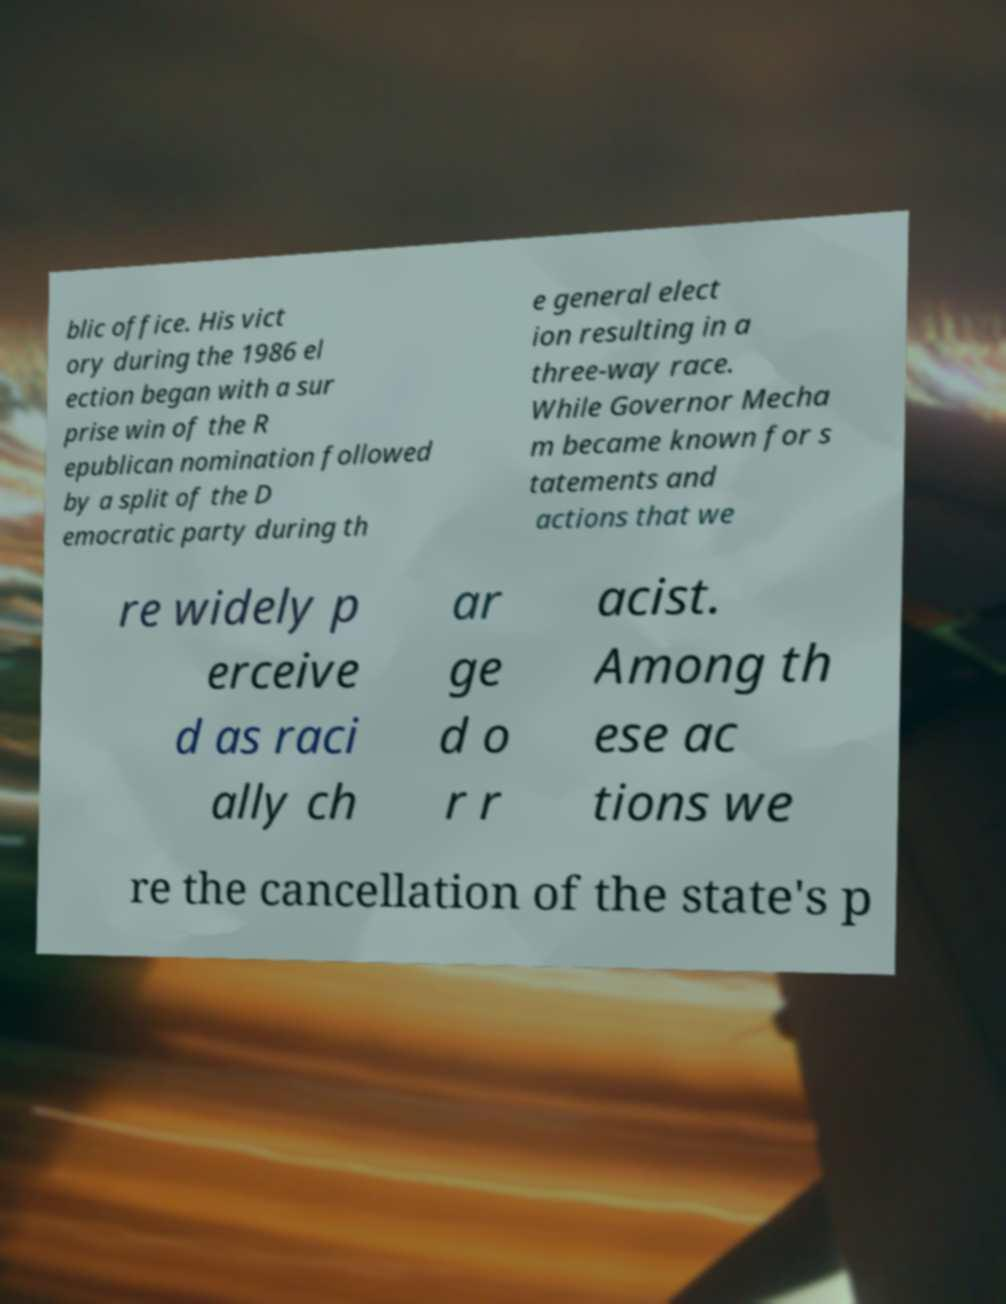I need the written content from this picture converted into text. Can you do that? blic office. His vict ory during the 1986 el ection began with a sur prise win of the R epublican nomination followed by a split of the D emocratic party during th e general elect ion resulting in a three-way race. While Governor Mecha m became known for s tatements and actions that we re widely p erceive d as raci ally ch ar ge d o r r acist. Among th ese ac tions we re the cancellation of the state's p 